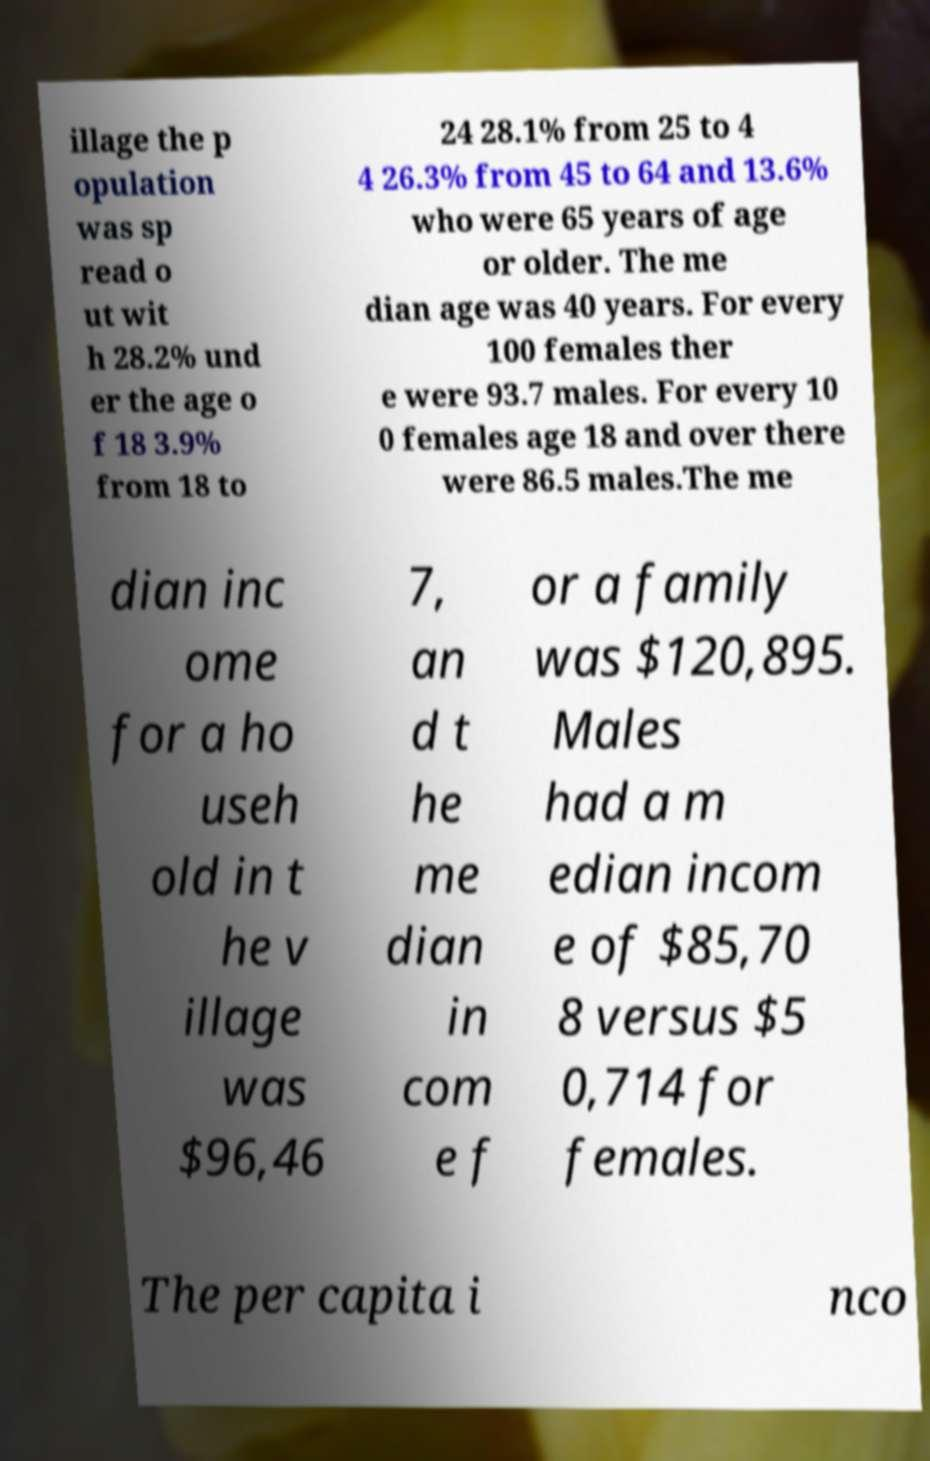Please read and relay the text visible in this image. What does it say? illage the p opulation was sp read o ut wit h 28.2% und er the age o f 18 3.9% from 18 to 24 28.1% from 25 to 4 4 26.3% from 45 to 64 and 13.6% who were 65 years of age or older. The me dian age was 40 years. For every 100 females ther e were 93.7 males. For every 10 0 females age 18 and over there were 86.5 males.The me dian inc ome for a ho useh old in t he v illage was $96,46 7, an d t he me dian in com e f or a family was $120,895. Males had a m edian incom e of $85,70 8 versus $5 0,714 for females. The per capita i nco 